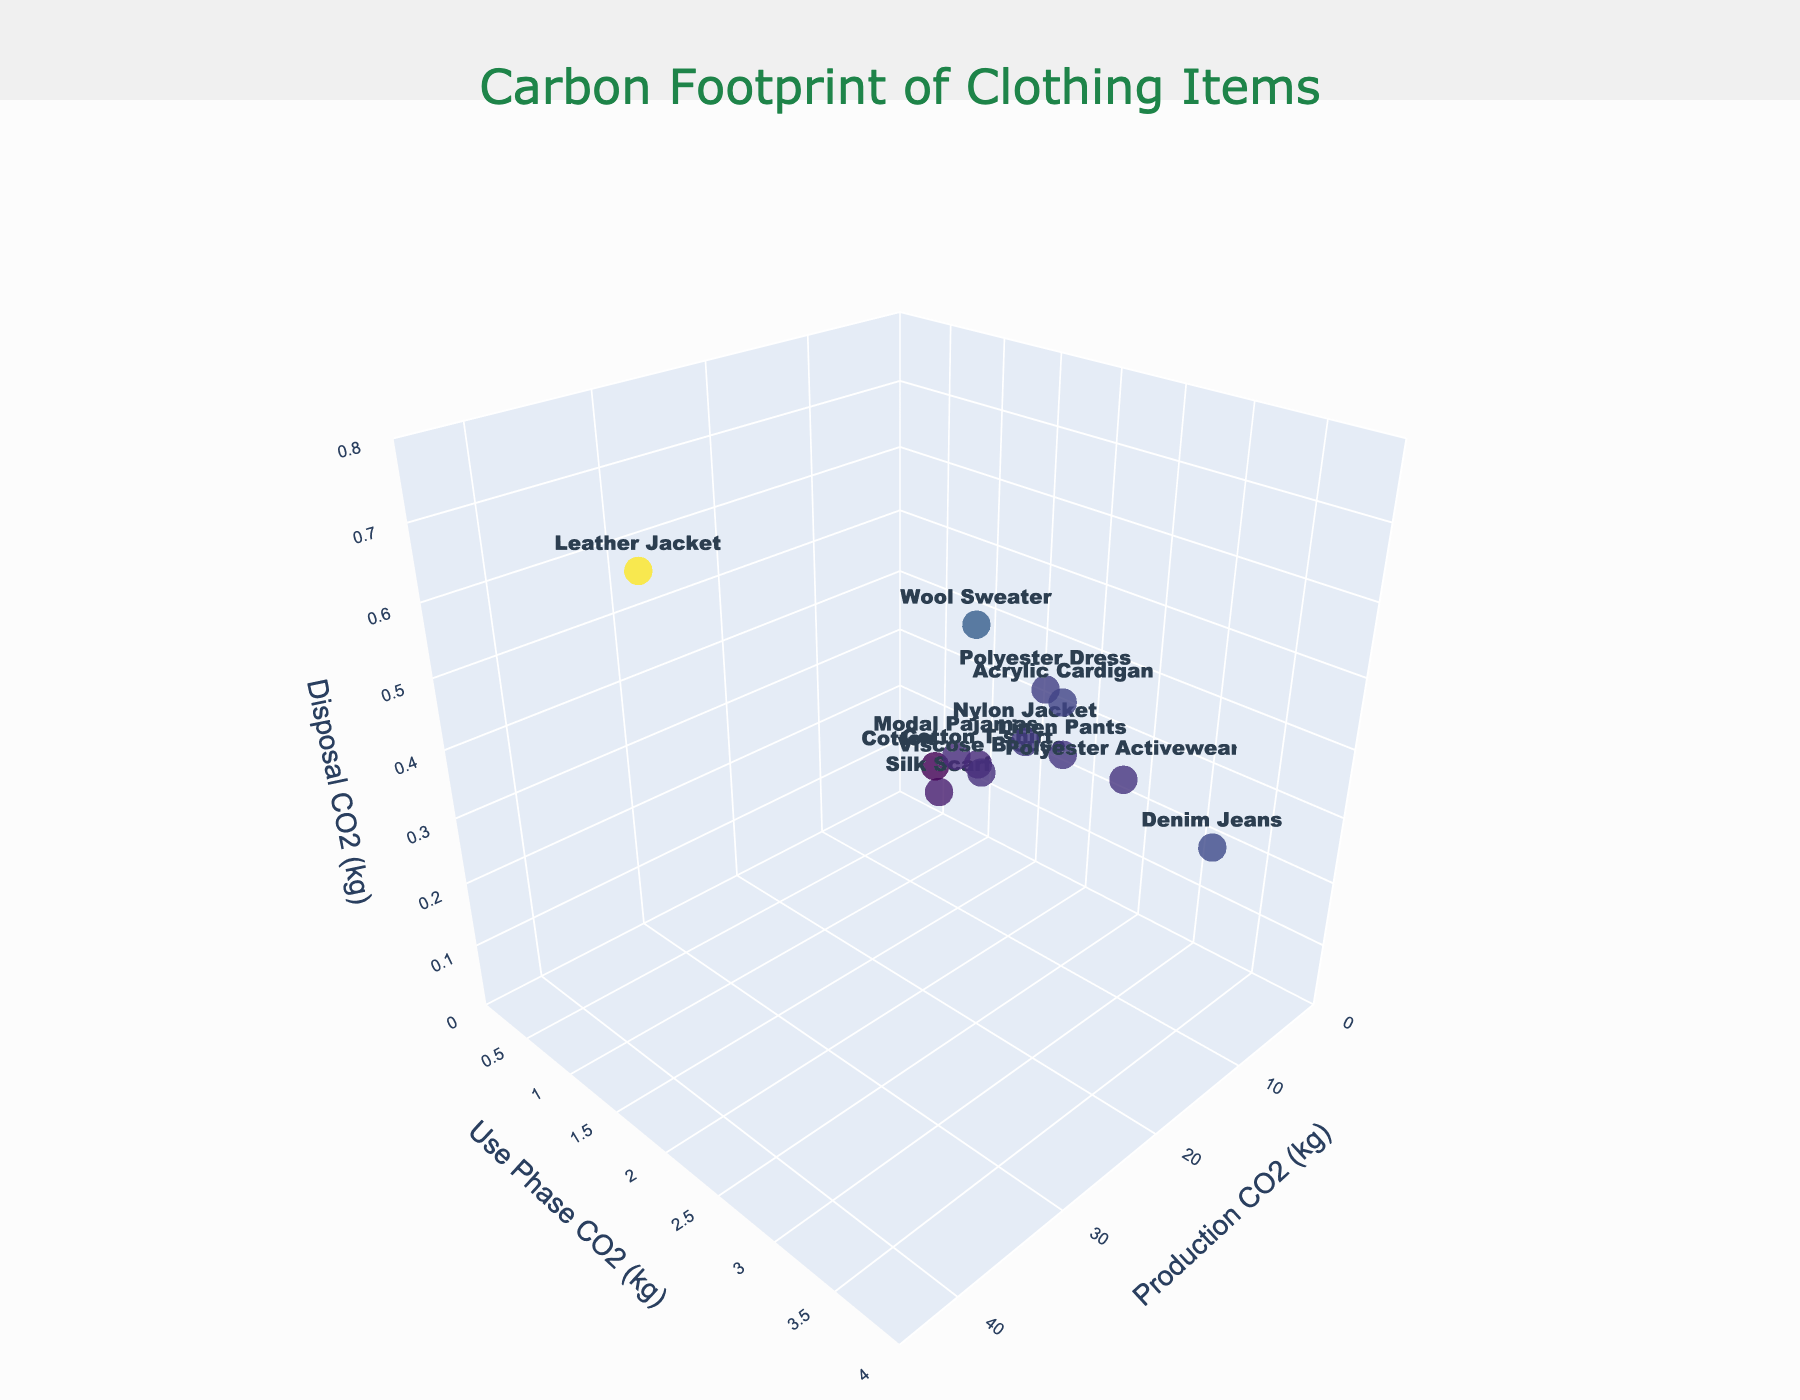Who has the highest Production CO2 among the clothing items? Look at the x-axis value (Production CO2) and find the item that has the largest value. The Leather Jacket has the highest production CO2 at 39.2 kg.
Answer: Leather Jacket Which clothing item has the lowest total CO2 emissions (sum of Production, Use Phase, and Disposal CO2)? Calculate the sum of Production, Use Phase, and Disposal CO2 for each item and identify the smallest value. The Silk Scarf has the lowest total CO2 emissions with a sum of 4.2 + 0.8 + 0.1 = 5.1 kg.
Answer: Silk Scarf How many clothing items have a Use Phase CO2 emission greater than 2 kg? Identify the items on the y-axis (Use Phase CO2) that have values greater than 2. There are 4 items: Polyester Dress, Denim Jeans, Acrylic Cardigan, and Polyester Activewear.
Answer: 4 Compare the Use Phase CO2 emissions between Denim Jeans and Linen Pants. Which one is higher? Check the y-axis values for both items. The Use Phase CO2 for Denim Jeans is 3.6 kg, and for Linen Pants, it is 2.2 kg. Therefore, Denim Jeans has higher Use Phase CO2 emissions.
Answer: Denim Jeans What's the average Disposal CO2 of all clothing items? Sum all Disposal CO2 values and divide by the number of items. The values are 0.2, 0.4, 0.3, 0.5, 0.7, 0.3, 0.2, 0.3, 0.1, 0.4, 0.1, 0.3, 0.2. The average = (0.2 + 0.4 + 0.3 + 0.5 + 0.7 + 0.3 + 0.2 + 0.3 + 0.1 + 0.4 + 0.1 + 0.3 + 0.2) / 13 ≈ 0.31 kg
Answer: 0.31 kg Which clothing item has simultaneously the highest Disposal CO2 and a Use Phase CO2 of less than 2 kg? Identify the item with the highest z-axis value (Disposal CO2) first, then check its y-axis value (Use Phase CO2) to see if it's less than 2 kg. The Leather Jacket has the highest Disposal CO2 of 0.7 kg and a Use Phase CO2 of 1.5 kg.
Answer: Leather Jacket What are the coordinates (Production CO2, Use Phase CO2, Disposal CO2) of the Cotton T-shirt? Refer to the values for the Cotton T-shirt and list them. The Production CO2 is 5.5, Use Phase CO2 is 1.3, and Disposal CO2 is 0.2 kg.
Answer: (5.5, 1.3, 0.2) Which item has a higher total CO2 emissions, Polyester Dress or Viscose Blouse? Calculate the total CO2 for each item. For Polyester Dress: 8.2 + 2.1 + 0.4 = 10.7 kg. For Viscose Blouse: 6.3 + 1.4 + 0.2 = 7.9 kg. Polyester Dress has higher total CO2 emissions.
Answer: Polyester Dress What is the total CO2 emissions of the clothing items with the highest Production CO2 and lowest Use Phase CO2? Identify the items first: the highest Production CO2 is Leather Jacket (39.2kg) and the lowest Use Phase CO2 is Silk Scarf (0.8kg). Sum their total CO2: Leather Jacket: 39.2 + 1.5 + 0.7 = 41.4 kg, Silk Scarf: 4.2 + 0.8 + 0.1 = 5.1 kg.
Answer: 41.4 kg What's the total Use Phase CO2 emissions for all clothing items? Sum all Use Phase CO2 emissions: 1.3, 2.1, 3.6, 1.8, 1.5, 1.9, 1.4, 2.2, 0.8, 2.3, 0.5, 2.7, 1.1. The total = 1.3 + 2.1 + 3.6 + 1.8 + 1.5 + 1.9 + 1.4 + 2.2 + 0.8 + 2.3 + 0.5 + 2.7 + 1.1 = 22.2 kg.
Answer: 22.2 kg 